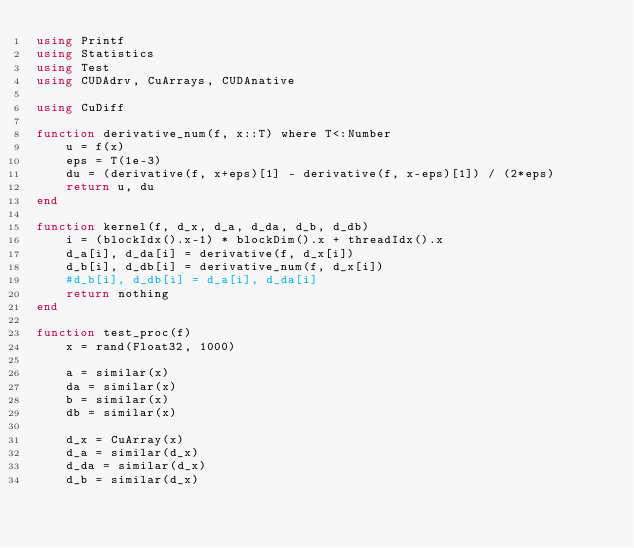Convert code to text. <code><loc_0><loc_0><loc_500><loc_500><_Julia_>using Printf
using Statistics
using Test
using CUDAdrv, CuArrays, CUDAnative

using CuDiff

function derivative_num(f, x::T) where T<:Number
    u = f(x)
    eps = T(1e-3)
    du = (derivative(f, x+eps)[1] - derivative(f, x-eps)[1]) / (2*eps)
    return u, du
end

function kernel(f, d_x, d_a, d_da, d_b, d_db)
    i = (blockIdx().x-1) * blockDim().x + threadIdx().x
    d_a[i], d_da[i] = derivative(f, d_x[i])
    d_b[i], d_db[i] = derivative_num(f, d_x[i])
    #d_b[i], d_db[i] = d_a[i], d_da[i]
    return nothing
end

function test_proc(f)
    x = rand(Float32, 1000)

    a = similar(x)
    da = similar(x)
    b = similar(x)
    db = similar(x)

    d_x = CuArray(x)
    d_a = similar(d_x)
    d_da = similar(d_x)
    d_b = similar(d_x)</code> 